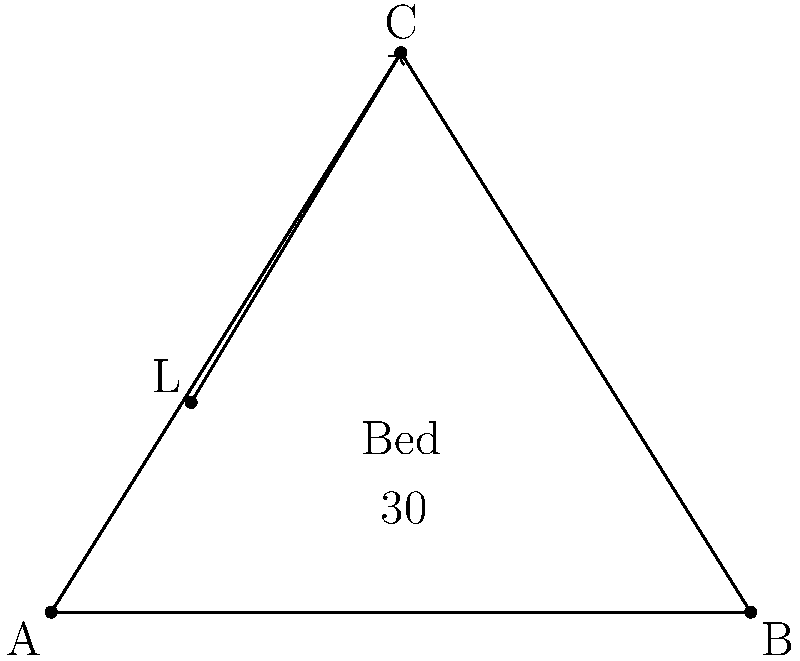In a staged bedroom, a lamp is placed at point L to create ambiance. If the bed is represented by side AB of the triangle, and the optimal lighting angle is 30° from the floor, at what height should the lamp be placed to achieve this angle when directed towards point C? To find the height of the lamp, we'll follow these steps:

1) First, we need to identify the known variables:
   - The bed is represented by side AB
   - The lamp is at point L
   - The desired angle is 30° from the floor
   - The light is directed towards point C

2) We can see that the lamp forms a right-angled triangle with its light beam and the floor.

3) In this right-angled triangle:
   - The angle at the floor is 30°
   - The hypotenuse is the light beam from L to C

4) We can use the sine function to find the height:

   $\sin(30°) = \frac{\text{opposite}}{\text{hypotenuse}} = \frac{\text{height}}{\text{LC}}$

5) We need to find the length of LC:
   LC² = (5-2)² + (8-3)² = 3² + 5² = 34

   $LC = \sqrt{34} \approx 5.83$ units

6) Now we can solve for the height:

   $\text{height} = LC \times \sin(30°)$
   $\text{height} = 5.83 \times 0.5 = 2.915$ units

7) Rounding to two decimal places, the height should be 2.92 units.
Answer: 2.92 units 